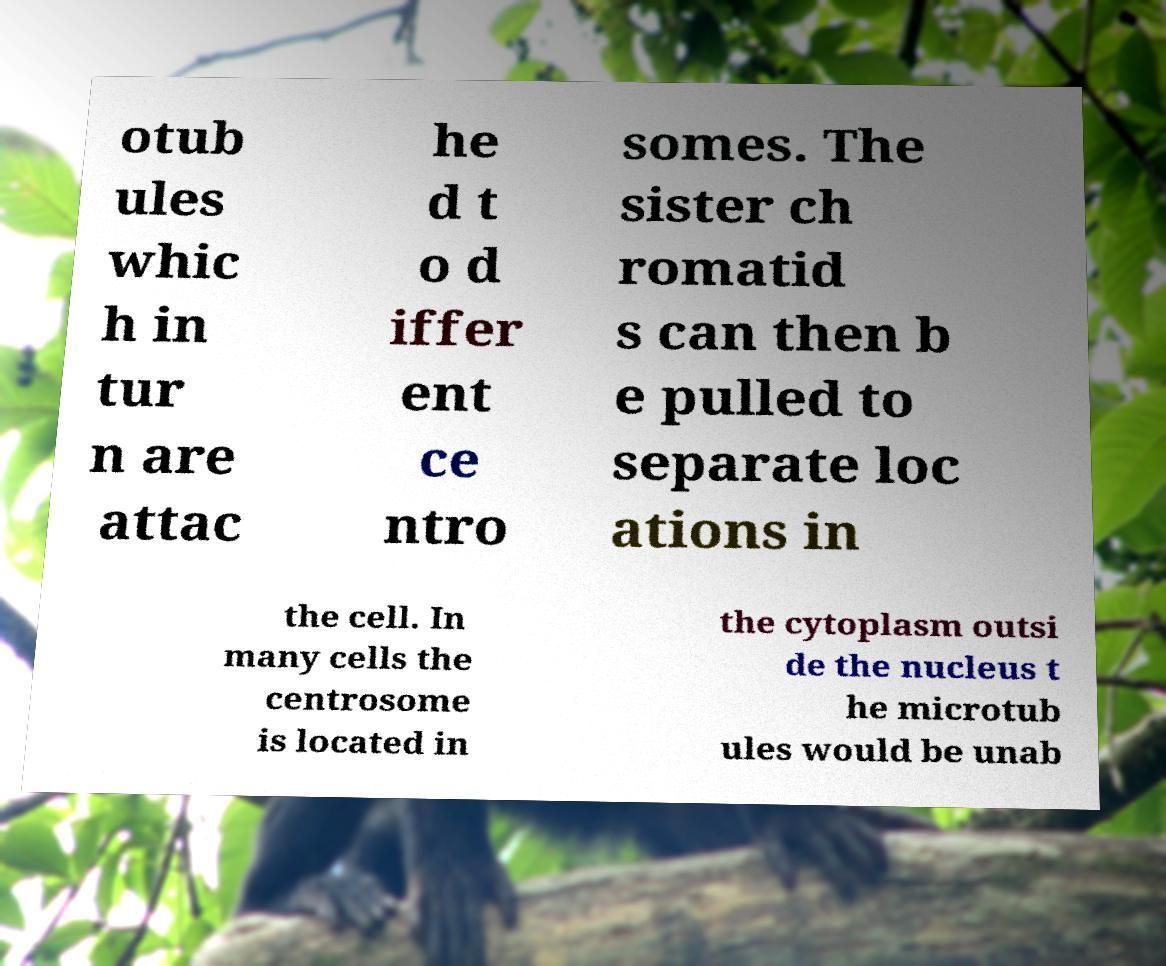Could you extract and type out the text from this image? otub ules whic h in tur n are attac he d t o d iffer ent ce ntro somes. The sister ch romatid s can then b e pulled to separate loc ations in the cell. In many cells the centrosome is located in the cytoplasm outsi de the nucleus t he microtub ules would be unab 